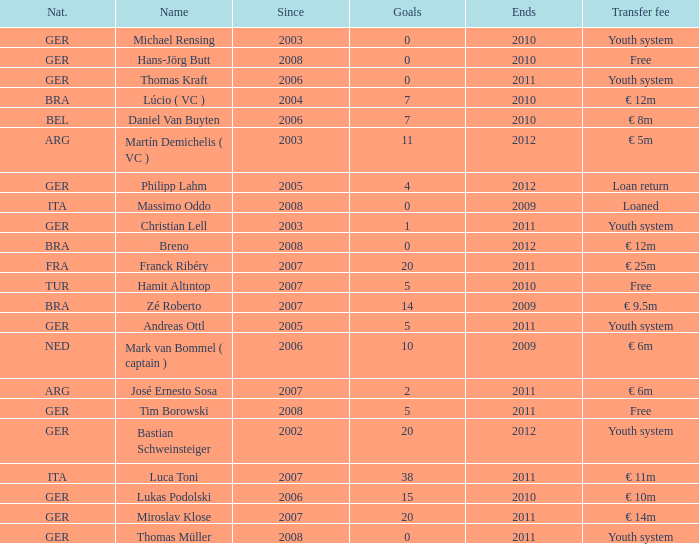What is the most initial year since that had a € 14m transfer fee and finished beyond 2011? None. 